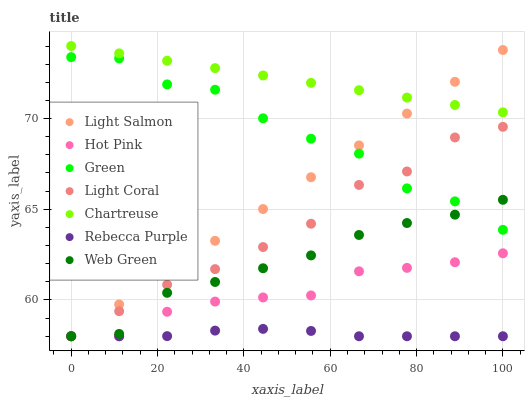Does Rebecca Purple have the minimum area under the curve?
Answer yes or no. Yes. Does Chartreuse have the maximum area under the curve?
Answer yes or no. Yes. Does Hot Pink have the minimum area under the curve?
Answer yes or no. No. Does Hot Pink have the maximum area under the curve?
Answer yes or no. No. Is Chartreuse the smoothest?
Answer yes or no. Yes. Is Green the roughest?
Answer yes or no. Yes. Is Hot Pink the smoothest?
Answer yes or no. No. Is Hot Pink the roughest?
Answer yes or no. No. Does Light Salmon have the lowest value?
Answer yes or no. Yes. Does Chartreuse have the lowest value?
Answer yes or no. No. Does Chartreuse have the highest value?
Answer yes or no. Yes. Does Hot Pink have the highest value?
Answer yes or no. No. Is Rebecca Purple less than Chartreuse?
Answer yes or no. Yes. Is Green greater than Hot Pink?
Answer yes or no. Yes. Does Light Salmon intersect Web Green?
Answer yes or no. Yes. Is Light Salmon less than Web Green?
Answer yes or no. No. Is Light Salmon greater than Web Green?
Answer yes or no. No. Does Rebecca Purple intersect Chartreuse?
Answer yes or no. No. 